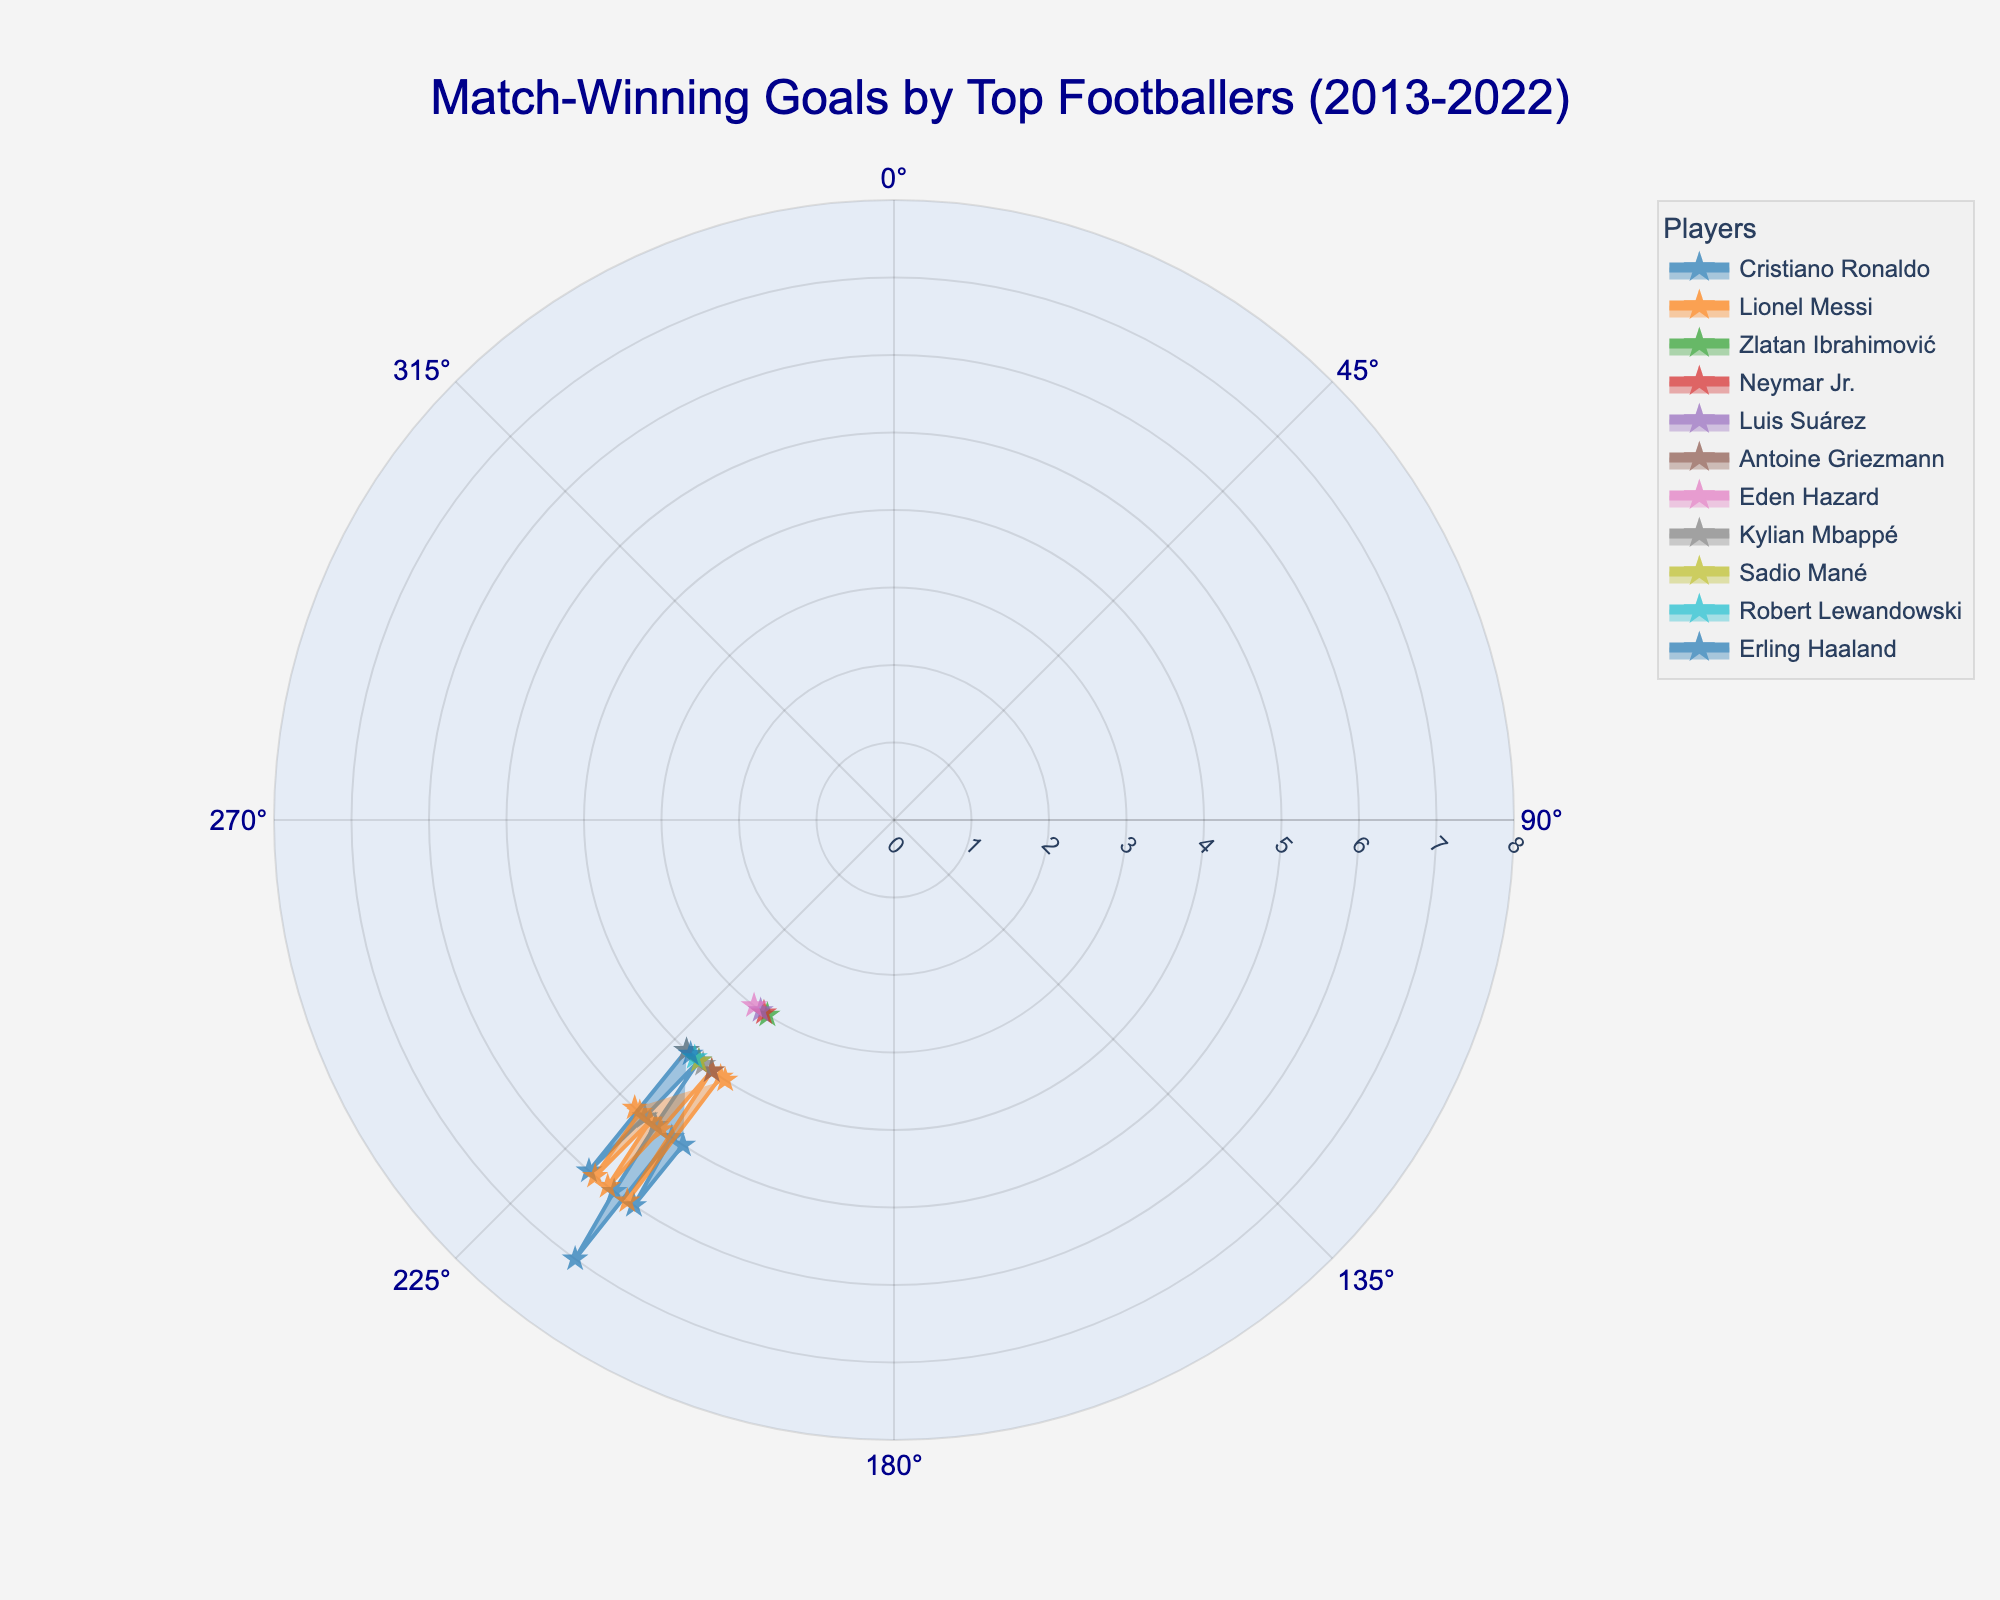How many match-winning goals did Lionel Messi score in 2019? To find this, look at the section of the polar area chart corresponding to the year 2019 and find the data point for Lionel Messi. The height of the segment tells you the match-winning goals he scored that year.
Answer: 5 Which player had the highest number of match-winning goals in 2016? Look for the segments representing different players in 2016 and identify the highest one. Cristiano Ronaldo's segment should be the largest, indicating the highest number of goals.
Answer: Cristiano Ronaldo Compare the match-winning goals of Lionel Messi and Cristiano Ronaldo in 2020. Who scored more? Check the heights of the segments for both players in the year 2020. Lionel Messi's segment is slightly higher than Cristiano Ronaldo's, indicating he scored more.
Answer: Lionel Messi What is the span of years covered in the chart? Refer to the axis labels indicating years around the circular axis. They range from the earliest to the latest year included in the chart.
Answer: 2013-2022 In which year did Cristiano Ronaldo have his highest number of match-winning goals? Identify the highest segment for Cristiano Ronaldo by checking around the circular axis for the year label. The segment with the highest value is in 2016.
Answer: 2016 List the nationalities of the players included in the chart. Look for the legends or annotations in the chart indicating the nationalities of players. These will mention Portugal, Argentina, Sweden, Brazil, Uruguay, France, Belgium, Senegal, Poland, and Norway.
Answer: Portugal, Argentina, Sweden, Brazil, Uruguay, France, Belgium, Senegal, Poland, Norway How many players scored at least 5 match-winning goals in 2018? Look at the segments for the year 2018 and count the number of players whose segments reach or exceed the '5' mark on the radial axis. There are two players: Lionel Messi and Cristiano Ronaldo.
Answer: 2 What's the average number of match-winning goals scored by Lionel Messi from 2013 to 2022? Locate the segments for Lionel Messi across all years, sum the numbers, and divide by the number of years. Summing (4 + 4 + 6 + 4 + 5 + 6 + 5 + 5 + 6 + 5) gives 50, and dividing by 10 gives an average of 5.
Answer: 5 Which player has consistently scored match-winning goals every year on the chart? Check for a player with segments in every year from 2013 to 2022. Both Lionel Messi and Cristiano Ronaldo have segments in every year, showing consistent scoring.
Answer: Lionel Messi, Cristiano Ronaldo What is the minimum number of match-winning goals scored by any player in a single year? Identify the lowest segment across all years and players. The smallest value observed in multiple years (such as 2013 for Zlatan Ibrahimović) is 3 match-winning goals.
Answer: 3 